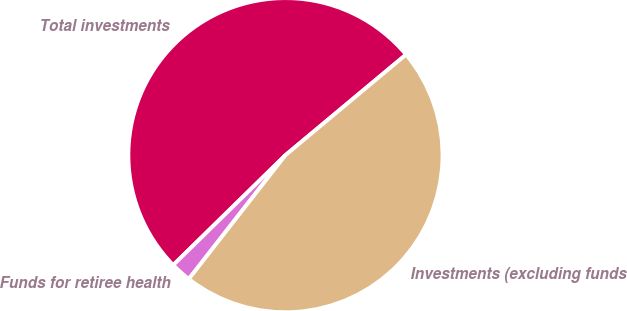Convert chart. <chart><loc_0><loc_0><loc_500><loc_500><pie_chart><fcel>Total investments<fcel>Funds for retiree health<fcel>Investments (excluding funds<nl><fcel>51.27%<fcel>2.12%<fcel>46.61%<nl></chart> 